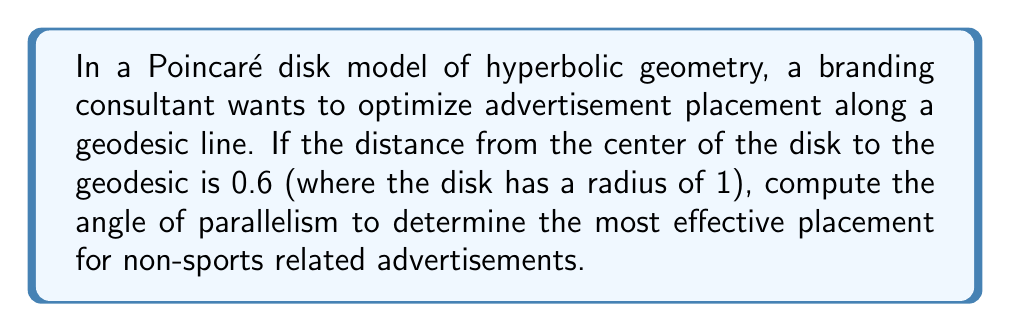Teach me how to tackle this problem. To solve this problem, we'll follow these steps:

1. Recall the formula for the angle of parallelism in the Poincaré disk model:
   $$\Pi(d) = 2 \arctan(e^{-d})$$
   where $d$ is the hyperbolic distance.

2. In the Poincaré disk model, the hyperbolic distance $d$ from the center to a point $(x,0)$ on the x-axis is given by:
   $$d = 2 \tanh^{-1}(x)$$

3. We're given that the Euclidean distance from the center to the geodesic is 0.6. Let's call this distance $r$. We need to find $x$ such that:
   $$\frac{x-r}{1-rx} = 0$$

4. Solving this equation:
   $$x-r = 0$$
   $$x = r = 0.6$$

5. Now we can calculate the hyperbolic distance:
   $$d = 2 \tanh^{-1}(0.6)$$

6. Let's compute this value:
   $$d = 2 \tanh^{-1}(0.6) \approx 1.3169578969248166$$

7. Now we can plug this into the angle of parallelism formula:
   $$\Pi(d) = 2 \arctan(e^{-1.3169578969248166})$$

8. Computing this:
   $$\Pi(d) \approx 0.9670596312279362 \text{ radians}$$

9. Converting to degrees:
   $$\Pi(d) \approx 55.40969070899155°$$

This angle represents the optimal placement for non-sports related advertisements along the geodesic line in the Poincaré disk model.
Answer: $55.41°$ 